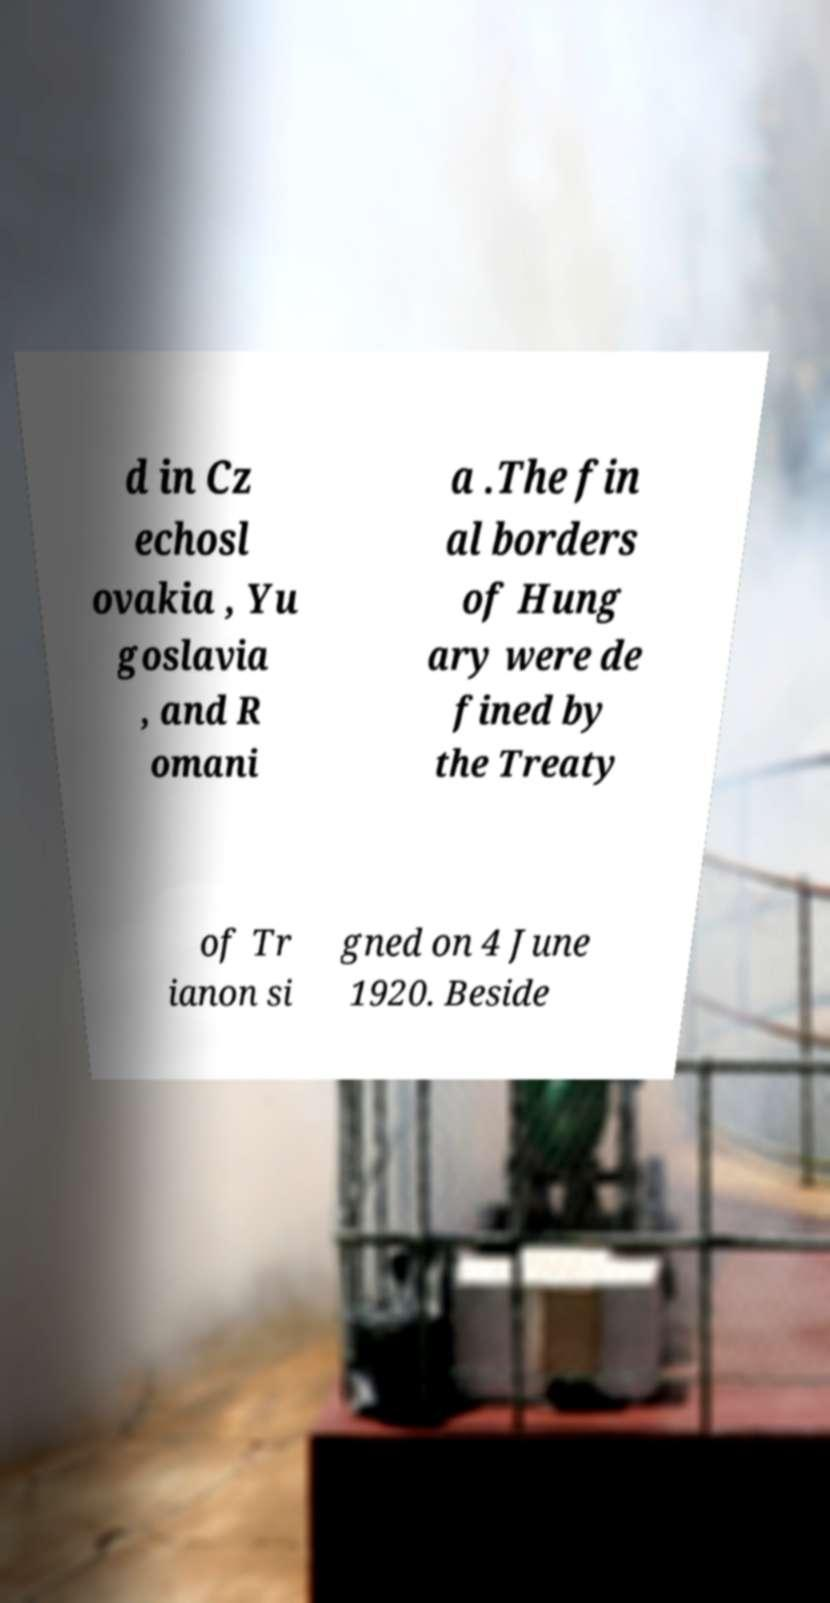There's text embedded in this image that I need extracted. Can you transcribe it verbatim? d in Cz echosl ovakia , Yu goslavia , and R omani a .The fin al borders of Hung ary were de fined by the Treaty of Tr ianon si gned on 4 June 1920. Beside 